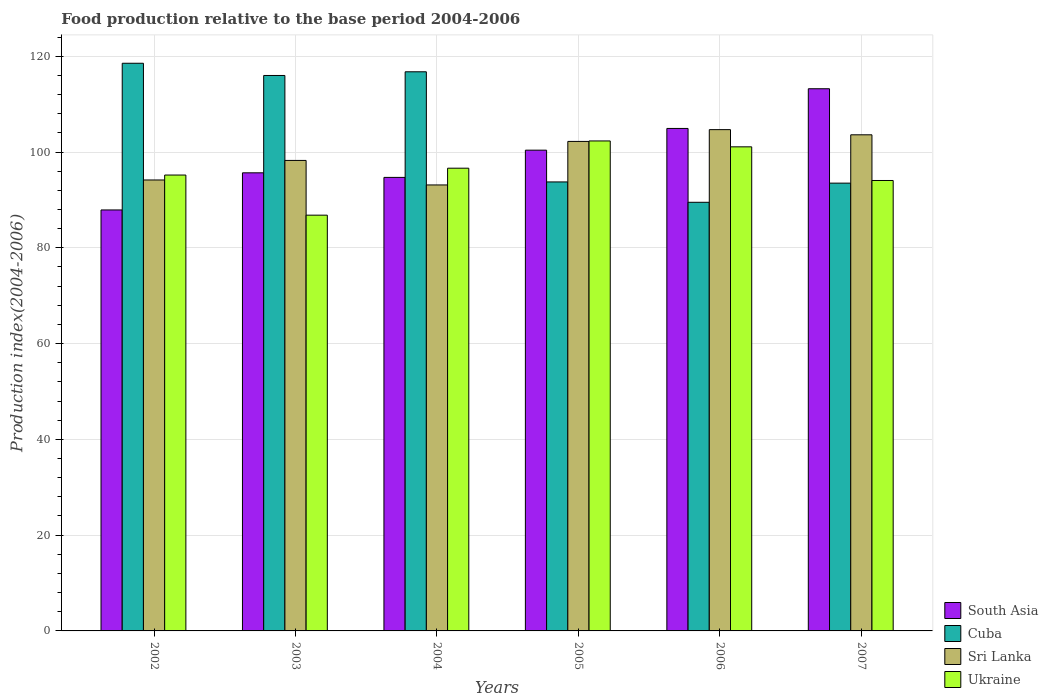In how many cases, is the number of bars for a given year not equal to the number of legend labels?
Your answer should be very brief. 0. What is the food production index in Sri Lanka in 2005?
Provide a short and direct response. 102.21. Across all years, what is the maximum food production index in Sri Lanka?
Provide a succinct answer. 104.67. Across all years, what is the minimum food production index in Sri Lanka?
Make the answer very short. 93.12. In which year was the food production index in South Asia minimum?
Your response must be concise. 2002. What is the total food production index in Cuba in the graph?
Ensure brevity in your answer.  628.01. What is the difference between the food production index in Ukraine in 2003 and that in 2005?
Provide a succinct answer. -15.5. What is the difference between the food production index in Sri Lanka in 2005 and the food production index in Ukraine in 2002?
Keep it short and to the point. 7.02. What is the average food production index in Cuba per year?
Your answer should be compact. 104.67. In the year 2006, what is the difference between the food production index in South Asia and food production index in Sri Lanka?
Provide a succinct answer. 0.25. In how many years, is the food production index in Cuba greater than 52?
Your answer should be very brief. 6. What is the ratio of the food production index in Ukraine in 2003 to that in 2007?
Keep it short and to the point. 0.92. What is the difference between the highest and the second highest food production index in Cuba?
Offer a terse response. 1.78. What is the difference between the highest and the lowest food production index in Cuba?
Your answer should be very brief. 29.03. Is it the case that in every year, the sum of the food production index in Cuba and food production index in South Asia is greater than the sum of food production index in Sri Lanka and food production index in Ukraine?
Give a very brief answer. Yes. What does the 2nd bar from the left in 2007 represents?
Your response must be concise. Cuba. What does the 3rd bar from the right in 2005 represents?
Offer a terse response. Cuba. How many years are there in the graph?
Your response must be concise. 6. Are the values on the major ticks of Y-axis written in scientific E-notation?
Provide a succinct answer. No. Does the graph contain any zero values?
Offer a terse response. No. Does the graph contain grids?
Provide a succinct answer. Yes. How are the legend labels stacked?
Ensure brevity in your answer.  Vertical. What is the title of the graph?
Your response must be concise. Food production relative to the base period 2004-2006. Does "Ukraine" appear as one of the legend labels in the graph?
Give a very brief answer. Yes. What is the label or title of the X-axis?
Offer a very short reply. Years. What is the label or title of the Y-axis?
Make the answer very short. Production index(2004-2006). What is the Production index(2004-2006) in South Asia in 2002?
Keep it short and to the point. 87.9. What is the Production index(2004-2006) in Cuba in 2002?
Your response must be concise. 118.53. What is the Production index(2004-2006) in Sri Lanka in 2002?
Your response must be concise. 94.16. What is the Production index(2004-2006) in Ukraine in 2002?
Your answer should be compact. 95.19. What is the Production index(2004-2006) of South Asia in 2003?
Make the answer very short. 95.65. What is the Production index(2004-2006) in Cuba in 2003?
Your answer should be very brief. 115.98. What is the Production index(2004-2006) in Sri Lanka in 2003?
Keep it short and to the point. 98.24. What is the Production index(2004-2006) of Ukraine in 2003?
Provide a short and direct response. 86.81. What is the Production index(2004-2006) of South Asia in 2004?
Your answer should be compact. 94.7. What is the Production index(2004-2006) of Cuba in 2004?
Your response must be concise. 116.75. What is the Production index(2004-2006) of Sri Lanka in 2004?
Your response must be concise. 93.12. What is the Production index(2004-2006) of Ukraine in 2004?
Your answer should be very brief. 96.62. What is the Production index(2004-2006) in South Asia in 2005?
Your answer should be compact. 100.38. What is the Production index(2004-2006) in Cuba in 2005?
Your response must be concise. 93.75. What is the Production index(2004-2006) of Sri Lanka in 2005?
Ensure brevity in your answer.  102.21. What is the Production index(2004-2006) in Ukraine in 2005?
Make the answer very short. 102.31. What is the Production index(2004-2006) of South Asia in 2006?
Provide a short and direct response. 104.92. What is the Production index(2004-2006) in Cuba in 2006?
Your answer should be very brief. 89.5. What is the Production index(2004-2006) in Sri Lanka in 2006?
Make the answer very short. 104.67. What is the Production index(2004-2006) of Ukraine in 2006?
Provide a short and direct response. 101.08. What is the Production index(2004-2006) in South Asia in 2007?
Offer a terse response. 113.21. What is the Production index(2004-2006) of Cuba in 2007?
Your response must be concise. 93.5. What is the Production index(2004-2006) in Sri Lanka in 2007?
Keep it short and to the point. 103.59. What is the Production index(2004-2006) in Ukraine in 2007?
Offer a very short reply. 94.05. Across all years, what is the maximum Production index(2004-2006) of South Asia?
Your answer should be very brief. 113.21. Across all years, what is the maximum Production index(2004-2006) of Cuba?
Offer a very short reply. 118.53. Across all years, what is the maximum Production index(2004-2006) in Sri Lanka?
Provide a succinct answer. 104.67. Across all years, what is the maximum Production index(2004-2006) of Ukraine?
Make the answer very short. 102.31. Across all years, what is the minimum Production index(2004-2006) in South Asia?
Provide a succinct answer. 87.9. Across all years, what is the minimum Production index(2004-2006) in Cuba?
Make the answer very short. 89.5. Across all years, what is the minimum Production index(2004-2006) in Sri Lanka?
Provide a short and direct response. 93.12. Across all years, what is the minimum Production index(2004-2006) in Ukraine?
Make the answer very short. 86.81. What is the total Production index(2004-2006) of South Asia in the graph?
Keep it short and to the point. 596.76. What is the total Production index(2004-2006) of Cuba in the graph?
Offer a terse response. 628.01. What is the total Production index(2004-2006) of Sri Lanka in the graph?
Provide a short and direct response. 595.99. What is the total Production index(2004-2006) in Ukraine in the graph?
Provide a succinct answer. 576.06. What is the difference between the Production index(2004-2006) in South Asia in 2002 and that in 2003?
Provide a succinct answer. -7.75. What is the difference between the Production index(2004-2006) of Cuba in 2002 and that in 2003?
Your answer should be compact. 2.55. What is the difference between the Production index(2004-2006) in Sri Lanka in 2002 and that in 2003?
Give a very brief answer. -4.08. What is the difference between the Production index(2004-2006) in Ukraine in 2002 and that in 2003?
Offer a very short reply. 8.38. What is the difference between the Production index(2004-2006) in South Asia in 2002 and that in 2004?
Provide a succinct answer. -6.8. What is the difference between the Production index(2004-2006) in Cuba in 2002 and that in 2004?
Provide a short and direct response. 1.78. What is the difference between the Production index(2004-2006) in Ukraine in 2002 and that in 2004?
Offer a very short reply. -1.43. What is the difference between the Production index(2004-2006) of South Asia in 2002 and that in 2005?
Your answer should be very brief. -12.48. What is the difference between the Production index(2004-2006) in Cuba in 2002 and that in 2005?
Make the answer very short. 24.78. What is the difference between the Production index(2004-2006) of Sri Lanka in 2002 and that in 2005?
Offer a terse response. -8.05. What is the difference between the Production index(2004-2006) in Ukraine in 2002 and that in 2005?
Keep it short and to the point. -7.12. What is the difference between the Production index(2004-2006) of South Asia in 2002 and that in 2006?
Your answer should be very brief. -17.02. What is the difference between the Production index(2004-2006) in Cuba in 2002 and that in 2006?
Your answer should be very brief. 29.03. What is the difference between the Production index(2004-2006) in Sri Lanka in 2002 and that in 2006?
Give a very brief answer. -10.51. What is the difference between the Production index(2004-2006) of Ukraine in 2002 and that in 2006?
Your response must be concise. -5.89. What is the difference between the Production index(2004-2006) of South Asia in 2002 and that in 2007?
Provide a short and direct response. -25.31. What is the difference between the Production index(2004-2006) of Cuba in 2002 and that in 2007?
Keep it short and to the point. 25.03. What is the difference between the Production index(2004-2006) of Sri Lanka in 2002 and that in 2007?
Give a very brief answer. -9.43. What is the difference between the Production index(2004-2006) in Ukraine in 2002 and that in 2007?
Make the answer very short. 1.14. What is the difference between the Production index(2004-2006) of South Asia in 2003 and that in 2004?
Keep it short and to the point. 0.96. What is the difference between the Production index(2004-2006) of Cuba in 2003 and that in 2004?
Ensure brevity in your answer.  -0.77. What is the difference between the Production index(2004-2006) of Sri Lanka in 2003 and that in 2004?
Give a very brief answer. 5.12. What is the difference between the Production index(2004-2006) of Ukraine in 2003 and that in 2004?
Make the answer very short. -9.81. What is the difference between the Production index(2004-2006) of South Asia in 2003 and that in 2005?
Your answer should be very brief. -4.73. What is the difference between the Production index(2004-2006) in Cuba in 2003 and that in 2005?
Make the answer very short. 22.23. What is the difference between the Production index(2004-2006) of Sri Lanka in 2003 and that in 2005?
Make the answer very short. -3.97. What is the difference between the Production index(2004-2006) in Ukraine in 2003 and that in 2005?
Your answer should be very brief. -15.5. What is the difference between the Production index(2004-2006) of South Asia in 2003 and that in 2006?
Keep it short and to the point. -9.26. What is the difference between the Production index(2004-2006) of Cuba in 2003 and that in 2006?
Keep it short and to the point. 26.48. What is the difference between the Production index(2004-2006) in Sri Lanka in 2003 and that in 2006?
Your answer should be compact. -6.43. What is the difference between the Production index(2004-2006) of Ukraine in 2003 and that in 2006?
Give a very brief answer. -14.27. What is the difference between the Production index(2004-2006) in South Asia in 2003 and that in 2007?
Provide a short and direct response. -17.55. What is the difference between the Production index(2004-2006) of Cuba in 2003 and that in 2007?
Provide a short and direct response. 22.48. What is the difference between the Production index(2004-2006) in Sri Lanka in 2003 and that in 2007?
Give a very brief answer. -5.35. What is the difference between the Production index(2004-2006) of Ukraine in 2003 and that in 2007?
Make the answer very short. -7.24. What is the difference between the Production index(2004-2006) of South Asia in 2004 and that in 2005?
Make the answer very short. -5.69. What is the difference between the Production index(2004-2006) of Sri Lanka in 2004 and that in 2005?
Ensure brevity in your answer.  -9.09. What is the difference between the Production index(2004-2006) in Ukraine in 2004 and that in 2005?
Ensure brevity in your answer.  -5.69. What is the difference between the Production index(2004-2006) in South Asia in 2004 and that in 2006?
Your response must be concise. -10.22. What is the difference between the Production index(2004-2006) in Cuba in 2004 and that in 2006?
Keep it short and to the point. 27.25. What is the difference between the Production index(2004-2006) in Sri Lanka in 2004 and that in 2006?
Offer a terse response. -11.55. What is the difference between the Production index(2004-2006) of Ukraine in 2004 and that in 2006?
Provide a succinct answer. -4.46. What is the difference between the Production index(2004-2006) in South Asia in 2004 and that in 2007?
Offer a very short reply. -18.51. What is the difference between the Production index(2004-2006) of Cuba in 2004 and that in 2007?
Ensure brevity in your answer.  23.25. What is the difference between the Production index(2004-2006) of Sri Lanka in 2004 and that in 2007?
Keep it short and to the point. -10.47. What is the difference between the Production index(2004-2006) in Ukraine in 2004 and that in 2007?
Keep it short and to the point. 2.57. What is the difference between the Production index(2004-2006) in South Asia in 2005 and that in 2006?
Make the answer very short. -4.53. What is the difference between the Production index(2004-2006) of Cuba in 2005 and that in 2006?
Provide a short and direct response. 4.25. What is the difference between the Production index(2004-2006) in Sri Lanka in 2005 and that in 2006?
Your answer should be very brief. -2.46. What is the difference between the Production index(2004-2006) in Ukraine in 2005 and that in 2006?
Keep it short and to the point. 1.23. What is the difference between the Production index(2004-2006) of South Asia in 2005 and that in 2007?
Offer a terse response. -12.82. What is the difference between the Production index(2004-2006) of Sri Lanka in 2005 and that in 2007?
Your answer should be compact. -1.38. What is the difference between the Production index(2004-2006) of Ukraine in 2005 and that in 2007?
Ensure brevity in your answer.  8.26. What is the difference between the Production index(2004-2006) of South Asia in 2006 and that in 2007?
Your response must be concise. -8.29. What is the difference between the Production index(2004-2006) of Cuba in 2006 and that in 2007?
Provide a succinct answer. -4. What is the difference between the Production index(2004-2006) in Sri Lanka in 2006 and that in 2007?
Provide a succinct answer. 1.08. What is the difference between the Production index(2004-2006) in Ukraine in 2006 and that in 2007?
Ensure brevity in your answer.  7.03. What is the difference between the Production index(2004-2006) of South Asia in 2002 and the Production index(2004-2006) of Cuba in 2003?
Provide a short and direct response. -28.08. What is the difference between the Production index(2004-2006) of South Asia in 2002 and the Production index(2004-2006) of Sri Lanka in 2003?
Ensure brevity in your answer.  -10.34. What is the difference between the Production index(2004-2006) in South Asia in 2002 and the Production index(2004-2006) in Ukraine in 2003?
Make the answer very short. 1.09. What is the difference between the Production index(2004-2006) in Cuba in 2002 and the Production index(2004-2006) in Sri Lanka in 2003?
Make the answer very short. 20.29. What is the difference between the Production index(2004-2006) of Cuba in 2002 and the Production index(2004-2006) of Ukraine in 2003?
Offer a terse response. 31.72. What is the difference between the Production index(2004-2006) in Sri Lanka in 2002 and the Production index(2004-2006) in Ukraine in 2003?
Give a very brief answer. 7.35. What is the difference between the Production index(2004-2006) of South Asia in 2002 and the Production index(2004-2006) of Cuba in 2004?
Give a very brief answer. -28.85. What is the difference between the Production index(2004-2006) in South Asia in 2002 and the Production index(2004-2006) in Sri Lanka in 2004?
Provide a short and direct response. -5.22. What is the difference between the Production index(2004-2006) of South Asia in 2002 and the Production index(2004-2006) of Ukraine in 2004?
Offer a terse response. -8.72. What is the difference between the Production index(2004-2006) in Cuba in 2002 and the Production index(2004-2006) in Sri Lanka in 2004?
Make the answer very short. 25.41. What is the difference between the Production index(2004-2006) in Cuba in 2002 and the Production index(2004-2006) in Ukraine in 2004?
Your response must be concise. 21.91. What is the difference between the Production index(2004-2006) in Sri Lanka in 2002 and the Production index(2004-2006) in Ukraine in 2004?
Give a very brief answer. -2.46. What is the difference between the Production index(2004-2006) of South Asia in 2002 and the Production index(2004-2006) of Cuba in 2005?
Ensure brevity in your answer.  -5.85. What is the difference between the Production index(2004-2006) of South Asia in 2002 and the Production index(2004-2006) of Sri Lanka in 2005?
Keep it short and to the point. -14.31. What is the difference between the Production index(2004-2006) in South Asia in 2002 and the Production index(2004-2006) in Ukraine in 2005?
Your answer should be very brief. -14.41. What is the difference between the Production index(2004-2006) of Cuba in 2002 and the Production index(2004-2006) of Sri Lanka in 2005?
Offer a terse response. 16.32. What is the difference between the Production index(2004-2006) of Cuba in 2002 and the Production index(2004-2006) of Ukraine in 2005?
Your answer should be compact. 16.22. What is the difference between the Production index(2004-2006) in Sri Lanka in 2002 and the Production index(2004-2006) in Ukraine in 2005?
Make the answer very short. -8.15. What is the difference between the Production index(2004-2006) of South Asia in 2002 and the Production index(2004-2006) of Sri Lanka in 2006?
Ensure brevity in your answer.  -16.77. What is the difference between the Production index(2004-2006) of South Asia in 2002 and the Production index(2004-2006) of Ukraine in 2006?
Make the answer very short. -13.18. What is the difference between the Production index(2004-2006) in Cuba in 2002 and the Production index(2004-2006) in Sri Lanka in 2006?
Provide a succinct answer. 13.86. What is the difference between the Production index(2004-2006) in Cuba in 2002 and the Production index(2004-2006) in Ukraine in 2006?
Ensure brevity in your answer.  17.45. What is the difference between the Production index(2004-2006) of Sri Lanka in 2002 and the Production index(2004-2006) of Ukraine in 2006?
Give a very brief answer. -6.92. What is the difference between the Production index(2004-2006) in South Asia in 2002 and the Production index(2004-2006) in Cuba in 2007?
Offer a terse response. -5.6. What is the difference between the Production index(2004-2006) of South Asia in 2002 and the Production index(2004-2006) of Sri Lanka in 2007?
Provide a short and direct response. -15.69. What is the difference between the Production index(2004-2006) in South Asia in 2002 and the Production index(2004-2006) in Ukraine in 2007?
Provide a succinct answer. -6.15. What is the difference between the Production index(2004-2006) of Cuba in 2002 and the Production index(2004-2006) of Sri Lanka in 2007?
Provide a short and direct response. 14.94. What is the difference between the Production index(2004-2006) in Cuba in 2002 and the Production index(2004-2006) in Ukraine in 2007?
Your answer should be compact. 24.48. What is the difference between the Production index(2004-2006) of Sri Lanka in 2002 and the Production index(2004-2006) of Ukraine in 2007?
Your response must be concise. 0.11. What is the difference between the Production index(2004-2006) of South Asia in 2003 and the Production index(2004-2006) of Cuba in 2004?
Give a very brief answer. -21.1. What is the difference between the Production index(2004-2006) in South Asia in 2003 and the Production index(2004-2006) in Sri Lanka in 2004?
Ensure brevity in your answer.  2.53. What is the difference between the Production index(2004-2006) in South Asia in 2003 and the Production index(2004-2006) in Ukraine in 2004?
Offer a terse response. -0.97. What is the difference between the Production index(2004-2006) in Cuba in 2003 and the Production index(2004-2006) in Sri Lanka in 2004?
Give a very brief answer. 22.86. What is the difference between the Production index(2004-2006) in Cuba in 2003 and the Production index(2004-2006) in Ukraine in 2004?
Your answer should be compact. 19.36. What is the difference between the Production index(2004-2006) of Sri Lanka in 2003 and the Production index(2004-2006) of Ukraine in 2004?
Provide a short and direct response. 1.62. What is the difference between the Production index(2004-2006) of South Asia in 2003 and the Production index(2004-2006) of Cuba in 2005?
Provide a succinct answer. 1.9. What is the difference between the Production index(2004-2006) in South Asia in 2003 and the Production index(2004-2006) in Sri Lanka in 2005?
Give a very brief answer. -6.56. What is the difference between the Production index(2004-2006) in South Asia in 2003 and the Production index(2004-2006) in Ukraine in 2005?
Give a very brief answer. -6.66. What is the difference between the Production index(2004-2006) of Cuba in 2003 and the Production index(2004-2006) of Sri Lanka in 2005?
Provide a succinct answer. 13.77. What is the difference between the Production index(2004-2006) in Cuba in 2003 and the Production index(2004-2006) in Ukraine in 2005?
Ensure brevity in your answer.  13.67. What is the difference between the Production index(2004-2006) of Sri Lanka in 2003 and the Production index(2004-2006) of Ukraine in 2005?
Your answer should be compact. -4.07. What is the difference between the Production index(2004-2006) of South Asia in 2003 and the Production index(2004-2006) of Cuba in 2006?
Make the answer very short. 6.15. What is the difference between the Production index(2004-2006) of South Asia in 2003 and the Production index(2004-2006) of Sri Lanka in 2006?
Keep it short and to the point. -9.02. What is the difference between the Production index(2004-2006) in South Asia in 2003 and the Production index(2004-2006) in Ukraine in 2006?
Keep it short and to the point. -5.43. What is the difference between the Production index(2004-2006) of Cuba in 2003 and the Production index(2004-2006) of Sri Lanka in 2006?
Keep it short and to the point. 11.31. What is the difference between the Production index(2004-2006) in Cuba in 2003 and the Production index(2004-2006) in Ukraine in 2006?
Provide a succinct answer. 14.9. What is the difference between the Production index(2004-2006) of Sri Lanka in 2003 and the Production index(2004-2006) of Ukraine in 2006?
Provide a short and direct response. -2.84. What is the difference between the Production index(2004-2006) in South Asia in 2003 and the Production index(2004-2006) in Cuba in 2007?
Ensure brevity in your answer.  2.15. What is the difference between the Production index(2004-2006) in South Asia in 2003 and the Production index(2004-2006) in Sri Lanka in 2007?
Your response must be concise. -7.94. What is the difference between the Production index(2004-2006) of South Asia in 2003 and the Production index(2004-2006) of Ukraine in 2007?
Make the answer very short. 1.6. What is the difference between the Production index(2004-2006) of Cuba in 2003 and the Production index(2004-2006) of Sri Lanka in 2007?
Your answer should be compact. 12.39. What is the difference between the Production index(2004-2006) of Cuba in 2003 and the Production index(2004-2006) of Ukraine in 2007?
Offer a terse response. 21.93. What is the difference between the Production index(2004-2006) in Sri Lanka in 2003 and the Production index(2004-2006) in Ukraine in 2007?
Keep it short and to the point. 4.19. What is the difference between the Production index(2004-2006) in South Asia in 2004 and the Production index(2004-2006) in Cuba in 2005?
Make the answer very short. 0.95. What is the difference between the Production index(2004-2006) in South Asia in 2004 and the Production index(2004-2006) in Sri Lanka in 2005?
Provide a succinct answer. -7.51. What is the difference between the Production index(2004-2006) of South Asia in 2004 and the Production index(2004-2006) of Ukraine in 2005?
Offer a very short reply. -7.61. What is the difference between the Production index(2004-2006) in Cuba in 2004 and the Production index(2004-2006) in Sri Lanka in 2005?
Make the answer very short. 14.54. What is the difference between the Production index(2004-2006) of Cuba in 2004 and the Production index(2004-2006) of Ukraine in 2005?
Keep it short and to the point. 14.44. What is the difference between the Production index(2004-2006) in Sri Lanka in 2004 and the Production index(2004-2006) in Ukraine in 2005?
Your answer should be very brief. -9.19. What is the difference between the Production index(2004-2006) of South Asia in 2004 and the Production index(2004-2006) of Cuba in 2006?
Offer a terse response. 5.2. What is the difference between the Production index(2004-2006) of South Asia in 2004 and the Production index(2004-2006) of Sri Lanka in 2006?
Provide a succinct answer. -9.97. What is the difference between the Production index(2004-2006) in South Asia in 2004 and the Production index(2004-2006) in Ukraine in 2006?
Give a very brief answer. -6.38. What is the difference between the Production index(2004-2006) in Cuba in 2004 and the Production index(2004-2006) in Sri Lanka in 2006?
Offer a terse response. 12.08. What is the difference between the Production index(2004-2006) of Cuba in 2004 and the Production index(2004-2006) of Ukraine in 2006?
Give a very brief answer. 15.67. What is the difference between the Production index(2004-2006) of Sri Lanka in 2004 and the Production index(2004-2006) of Ukraine in 2006?
Provide a short and direct response. -7.96. What is the difference between the Production index(2004-2006) in South Asia in 2004 and the Production index(2004-2006) in Cuba in 2007?
Your answer should be compact. 1.2. What is the difference between the Production index(2004-2006) of South Asia in 2004 and the Production index(2004-2006) of Sri Lanka in 2007?
Offer a very short reply. -8.89. What is the difference between the Production index(2004-2006) of South Asia in 2004 and the Production index(2004-2006) of Ukraine in 2007?
Offer a terse response. 0.65. What is the difference between the Production index(2004-2006) in Cuba in 2004 and the Production index(2004-2006) in Sri Lanka in 2007?
Keep it short and to the point. 13.16. What is the difference between the Production index(2004-2006) in Cuba in 2004 and the Production index(2004-2006) in Ukraine in 2007?
Offer a very short reply. 22.7. What is the difference between the Production index(2004-2006) of Sri Lanka in 2004 and the Production index(2004-2006) of Ukraine in 2007?
Your answer should be compact. -0.93. What is the difference between the Production index(2004-2006) in South Asia in 2005 and the Production index(2004-2006) in Cuba in 2006?
Keep it short and to the point. 10.88. What is the difference between the Production index(2004-2006) of South Asia in 2005 and the Production index(2004-2006) of Sri Lanka in 2006?
Offer a very short reply. -4.29. What is the difference between the Production index(2004-2006) in South Asia in 2005 and the Production index(2004-2006) in Ukraine in 2006?
Give a very brief answer. -0.7. What is the difference between the Production index(2004-2006) in Cuba in 2005 and the Production index(2004-2006) in Sri Lanka in 2006?
Give a very brief answer. -10.92. What is the difference between the Production index(2004-2006) of Cuba in 2005 and the Production index(2004-2006) of Ukraine in 2006?
Provide a short and direct response. -7.33. What is the difference between the Production index(2004-2006) in Sri Lanka in 2005 and the Production index(2004-2006) in Ukraine in 2006?
Offer a terse response. 1.13. What is the difference between the Production index(2004-2006) of South Asia in 2005 and the Production index(2004-2006) of Cuba in 2007?
Your answer should be compact. 6.88. What is the difference between the Production index(2004-2006) in South Asia in 2005 and the Production index(2004-2006) in Sri Lanka in 2007?
Keep it short and to the point. -3.21. What is the difference between the Production index(2004-2006) of South Asia in 2005 and the Production index(2004-2006) of Ukraine in 2007?
Provide a succinct answer. 6.33. What is the difference between the Production index(2004-2006) in Cuba in 2005 and the Production index(2004-2006) in Sri Lanka in 2007?
Your response must be concise. -9.84. What is the difference between the Production index(2004-2006) of Cuba in 2005 and the Production index(2004-2006) of Ukraine in 2007?
Make the answer very short. -0.3. What is the difference between the Production index(2004-2006) in Sri Lanka in 2005 and the Production index(2004-2006) in Ukraine in 2007?
Provide a succinct answer. 8.16. What is the difference between the Production index(2004-2006) in South Asia in 2006 and the Production index(2004-2006) in Cuba in 2007?
Your answer should be very brief. 11.42. What is the difference between the Production index(2004-2006) in South Asia in 2006 and the Production index(2004-2006) in Sri Lanka in 2007?
Offer a very short reply. 1.33. What is the difference between the Production index(2004-2006) of South Asia in 2006 and the Production index(2004-2006) of Ukraine in 2007?
Provide a succinct answer. 10.87. What is the difference between the Production index(2004-2006) of Cuba in 2006 and the Production index(2004-2006) of Sri Lanka in 2007?
Keep it short and to the point. -14.09. What is the difference between the Production index(2004-2006) in Cuba in 2006 and the Production index(2004-2006) in Ukraine in 2007?
Offer a terse response. -4.55. What is the difference between the Production index(2004-2006) in Sri Lanka in 2006 and the Production index(2004-2006) in Ukraine in 2007?
Your answer should be very brief. 10.62. What is the average Production index(2004-2006) of South Asia per year?
Your answer should be compact. 99.46. What is the average Production index(2004-2006) of Cuba per year?
Your response must be concise. 104.67. What is the average Production index(2004-2006) in Sri Lanka per year?
Provide a succinct answer. 99.33. What is the average Production index(2004-2006) in Ukraine per year?
Provide a succinct answer. 96.01. In the year 2002, what is the difference between the Production index(2004-2006) in South Asia and Production index(2004-2006) in Cuba?
Your answer should be very brief. -30.63. In the year 2002, what is the difference between the Production index(2004-2006) in South Asia and Production index(2004-2006) in Sri Lanka?
Your answer should be very brief. -6.26. In the year 2002, what is the difference between the Production index(2004-2006) in South Asia and Production index(2004-2006) in Ukraine?
Ensure brevity in your answer.  -7.29. In the year 2002, what is the difference between the Production index(2004-2006) in Cuba and Production index(2004-2006) in Sri Lanka?
Provide a succinct answer. 24.37. In the year 2002, what is the difference between the Production index(2004-2006) in Cuba and Production index(2004-2006) in Ukraine?
Provide a short and direct response. 23.34. In the year 2002, what is the difference between the Production index(2004-2006) in Sri Lanka and Production index(2004-2006) in Ukraine?
Make the answer very short. -1.03. In the year 2003, what is the difference between the Production index(2004-2006) in South Asia and Production index(2004-2006) in Cuba?
Provide a succinct answer. -20.33. In the year 2003, what is the difference between the Production index(2004-2006) in South Asia and Production index(2004-2006) in Sri Lanka?
Your answer should be very brief. -2.59. In the year 2003, what is the difference between the Production index(2004-2006) of South Asia and Production index(2004-2006) of Ukraine?
Give a very brief answer. 8.84. In the year 2003, what is the difference between the Production index(2004-2006) of Cuba and Production index(2004-2006) of Sri Lanka?
Offer a very short reply. 17.74. In the year 2003, what is the difference between the Production index(2004-2006) of Cuba and Production index(2004-2006) of Ukraine?
Offer a very short reply. 29.17. In the year 2003, what is the difference between the Production index(2004-2006) of Sri Lanka and Production index(2004-2006) of Ukraine?
Your answer should be compact. 11.43. In the year 2004, what is the difference between the Production index(2004-2006) in South Asia and Production index(2004-2006) in Cuba?
Provide a short and direct response. -22.05. In the year 2004, what is the difference between the Production index(2004-2006) in South Asia and Production index(2004-2006) in Sri Lanka?
Provide a short and direct response. 1.58. In the year 2004, what is the difference between the Production index(2004-2006) in South Asia and Production index(2004-2006) in Ukraine?
Ensure brevity in your answer.  -1.92. In the year 2004, what is the difference between the Production index(2004-2006) of Cuba and Production index(2004-2006) of Sri Lanka?
Your answer should be compact. 23.63. In the year 2004, what is the difference between the Production index(2004-2006) of Cuba and Production index(2004-2006) of Ukraine?
Your response must be concise. 20.13. In the year 2005, what is the difference between the Production index(2004-2006) in South Asia and Production index(2004-2006) in Cuba?
Your answer should be compact. 6.63. In the year 2005, what is the difference between the Production index(2004-2006) in South Asia and Production index(2004-2006) in Sri Lanka?
Ensure brevity in your answer.  -1.83. In the year 2005, what is the difference between the Production index(2004-2006) of South Asia and Production index(2004-2006) of Ukraine?
Provide a short and direct response. -1.93. In the year 2005, what is the difference between the Production index(2004-2006) of Cuba and Production index(2004-2006) of Sri Lanka?
Keep it short and to the point. -8.46. In the year 2005, what is the difference between the Production index(2004-2006) of Cuba and Production index(2004-2006) of Ukraine?
Provide a succinct answer. -8.56. In the year 2006, what is the difference between the Production index(2004-2006) of South Asia and Production index(2004-2006) of Cuba?
Provide a succinct answer. 15.42. In the year 2006, what is the difference between the Production index(2004-2006) of South Asia and Production index(2004-2006) of Sri Lanka?
Your answer should be compact. 0.25. In the year 2006, what is the difference between the Production index(2004-2006) in South Asia and Production index(2004-2006) in Ukraine?
Give a very brief answer. 3.84. In the year 2006, what is the difference between the Production index(2004-2006) in Cuba and Production index(2004-2006) in Sri Lanka?
Your response must be concise. -15.17. In the year 2006, what is the difference between the Production index(2004-2006) in Cuba and Production index(2004-2006) in Ukraine?
Offer a terse response. -11.58. In the year 2006, what is the difference between the Production index(2004-2006) of Sri Lanka and Production index(2004-2006) of Ukraine?
Ensure brevity in your answer.  3.59. In the year 2007, what is the difference between the Production index(2004-2006) in South Asia and Production index(2004-2006) in Cuba?
Your answer should be compact. 19.71. In the year 2007, what is the difference between the Production index(2004-2006) in South Asia and Production index(2004-2006) in Sri Lanka?
Ensure brevity in your answer.  9.62. In the year 2007, what is the difference between the Production index(2004-2006) in South Asia and Production index(2004-2006) in Ukraine?
Give a very brief answer. 19.16. In the year 2007, what is the difference between the Production index(2004-2006) of Cuba and Production index(2004-2006) of Sri Lanka?
Ensure brevity in your answer.  -10.09. In the year 2007, what is the difference between the Production index(2004-2006) in Cuba and Production index(2004-2006) in Ukraine?
Give a very brief answer. -0.55. In the year 2007, what is the difference between the Production index(2004-2006) in Sri Lanka and Production index(2004-2006) in Ukraine?
Ensure brevity in your answer.  9.54. What is the ratio of the Production index(2004-2006) of South Asia in 2002 to that in 2003?
Make the answer very short. 0.92. What is the ratio of the Production index(2004-2006) in Cuba in 2002 to that in 2003?
Your answer should be compact. 1.02. What is the ratio of the Production index(2004-2006) of Sri Lanka in 2002 to that in 2003?
Your response must be concise. 0.96. What is the ratio of the Production index(2004-2006) in Ukraine in 2002 to that in 2003?
Provide a succinct answer. 1.1. What is the ratio of the Production index(2004-2006) in South Asia in 2002 to that in 2004?
Provide a succinct answer. 0.93. What is the ratio of the Production index(2004-2006) of Cuba in 2002 to that in 2004?
Make the answer very short. 1.02. What is the ratio of the Production index(2004-2006) in Sri Lanka in 2002 to that in 2004?
Your answer should be very brief. 1.01. What is the ratio of the Production index(2004-2006) of Ukraine in 2002 to that in 2004?
Your response must be concise. 0.99. What is the ratio of the Production index(2004-2006) in South Asia in 2002 to that in 2005?
Provide a short and direct response. 0.88. What is the ratio of the Production index(2004-2006) of Cuba in 2002 to that in 2005?
Give a very brief answer. 1.26. What is the ratio of the Production index(2004-2006) of Sri Lanka in 2002 to that in 2005?
Keep it short and to the point. 0.92. What is the ratio of the Production index(2004-2006) of Ukraine in 2002 to that in 2005?
Your response must be concise. 0.93. What is the ratio of the Production index(2004-2006) of South Asia in 2002 to that in 2006?
Keep it short and to the point. 0.84. What is the ratio of the Production index(2004-2006) of Cuba in 2002 to that in 2006?
Ensure brevity in your answer.  1.32. What is the ratio of the Production index(2004-2006) of Sri Lanka in 2002 to that in 2006?
Your answer should be compact. 0.9. What is the ratio of the Production index(2004-2006) in Ukraine in 2002 to that in 2006?
Offer a terse response. 0.94. What is the ratio of the Production index(2004-2006) of South Asia in 2002 to that in 2007?
Offer a very short reply. 0.78. What is the ratio of the Production index(2004-2006) in Cuba in 2002 to that in 2007?
Offer a very short reply. 1.27. What is the ratio of the Production index(2004-2006) in Sri Lanka in 2002 to that in 2007?
Ensure brevity in your answer.  0.91. What is the ratio of the Production index(2004-2006) in Ukraine in 2002 to that in 2007?
Provide a short and direct response. 1.01. What is the ratio of the Production index(2004-2006) of South Asia in 2003 to that in 2004?
Provide a short and direct response. 1.01. What is the ratio of the Production index(2004-2006) in Cuba in 2003 to that in 2004?
Make the answer very short. 0.99. What is the ratio of the Production index(2004-2006) in Sri Lanka in 2003 to that in 2004?
Provide a succinct answer. 1.05. What is the ratio of the Production index(2004-2006) in Ukraine in 2003 to that in 2004?
Your response must be concise. 0.9. What is the ratio of the Production index(2004-2006) of South Asia in 2003 to that in 2005?
Offer a very short reply. 0.95. What is the ratio of the Production index(2004-2006) of Cuba in 2003 to that in 2005?
Offer a very short reply. 1.24. What is the ratio of the Production index(2004-2006) of Sri Lanka in 2003 to that in 2005?
Keep it short and to the point. 0.96. What is the ratio of the Production index(2004-2006) in Ukraine in 2003 to that in 2005?
Your answer should be very brief. 0.85. What is the ratio of the Production index(2004-2006) of South Asia in 2003 to that in 2006?
Ensure brevity in your answer.  0.91. What is the ratio of the Production index(2004-2006) in Cuba in 2003 to that in 2006?
Ensure brevity in your answer.  1.3. What is the ratio of the Production index(2004-2006) of Sri Lanka in 2003 to that in 2006?
Provide a succinct answer. 0.94. What is the ratio of the Production index(2004-2006) in Ukraine in 2003 to that in 2006?
Make the answer very short. 0.86. What is the ratio of the Production index(2004-2006) of South Asia in 2003 to that in 2007?
Keep it short and to the point. 0.84. What is the ratio of the Production index(2004-2006) in Cuba in 2003 to that in 2007?
Give a very brief answer. 1.24. What is the ratio of the Production index(2004-2006) of Sri Lanka in 2003 to that in 2007?
Ensure brevity in your answer.  0.95. What is the ratio of the Production index(2004-2006) of Ukraine in 2003 to that in 2007?
Give a very brief answer. 0.92. What is the ratio of the Production index(2004-2006) of South Asia in 2004 to that in 2005?
Provide a succinct answer. 0.94. What is the ratio of the Production index(2004-2006) of Cuba in 2004 to that in 2005?
Offer a terse response. 1.25. What is the ratio of the Production index(2004-2006) of Sri Lanka in 2004 to that in 2005?
Your answer should be compact. 0.91. What is the ratio of the Production index(2004-2006) of South Asia in 2004 to that in 2006?
Ensure brevity in your answer.  0.9. What is the ratio of the Production index(2004-2006) of Cuba in 2004 to that in 2006?
Provide a succinct answer. 1.3. What is the ratio of the Production index(2004-2006) of Sri Lanka in 2004 to that in 2006?
Ensure brevity in your answer.  0.89. What is the ratio of the Production index(2004-2006) in Ukraine in 2004 to that in 2006?
Provide a succinct answer. 0.96. What is the ratio of the Production index(2004-2006) in South Asia in 2004 to that in 2007?
Provide a short and direct response. 0.84. What is the ratio of the Production index(2004-2006) in Cuba in 2004 to that in 2007?
Provide a short and direct response. 1.25. What is the ratio of the Production index(2004-2006) of Sri Lanka in 2004 to that in 2007?
Give a very brief answer. 0.9. What is the ratio of the Production index(2004-2006) of Ukraine in 2004 to that in 2007?
Ensure brevity in your answer.  1.03. What is the ratio of the Production index(2004-2006) of South Asia in 2005 to that in 2006?
Offer a terse response. 0.96. What is the ratio of the Production index(2004-2006) in Cuba in 2005 to that in 2006?
Provide a succinct answer. 1.05. What is the ratio of the Production index(2004-2006) in Sri Lanka in 2005 to that in 2006?
Give a very brief answer. 0.98. What is the ratio of the Production index(2004-2006) of Ukraine in 2005 to that in 2006?
Ensure brevity in your answer.  1.01. What is the ratio of the Production index(2004-2006) of South Asia in 2005 to that in 2007?
Your response must be concise. 0.89. What is the ratio of the Production index(2004-2006) in Cuba in 2005 to that in 2007?
Provide a succinct answer. 1. What is the ratio of the Production index(2004-2006) in Sri Lanka in 2005 to that in 2007?
Provide a short and direct response. 0.99. What is the ratio of the Production index(2004-2006) of Ukraine in 2005 to that in 2007?
Give a very brief answer. 1.09. What is the ratio of the Production index(2004-2006) in South Asia in 2006 to that in 2007?
Keep it short and to the point. 0.93. What is the ratio of the Production index(2004-2006) in Cuba in 2006 to that in 2007?
Offer a very short reply. 0.96. What is the ratio of the Production index(2004-2006) of Sri Lanka in 2006 to that in 2007?
Ensure brevity in your answer.  1.01. What is the ratio of the Production index(2004-2006) in Ukraine in 2006 to that in 2007?
Your answer should be very brief. 1.07. What is the difference between the highest and the second highest Production index(2004-2006) of South Asia?
Make the answer very short. 8.29. What is the difference between the highest and the second highest Production index(2004-2006) in Cuba?
Provide a succinct answer. 1.78. What is the difference between the highest and the second highest Production index(2004-2006) in Ukraine?
Provide a short and direct response. 1.23. What is the difference between the highest and the lowest Production index(2004-2006) in South Asia?
Make the answer very short. 25.31. What is the difference between the highest and the lowest Production index(2004-2006) of Cuba?
Offer a very short reply. 29.03. What is the difference between the highest and the lowest Production index(2004-2006) in Sri Lanka?
Ensure brevity in your answer.  11.55. What is the difference between the highest and the lowest Production index(2004-2006) in Ukraine?
Your answer should be very brief. 15.5. 